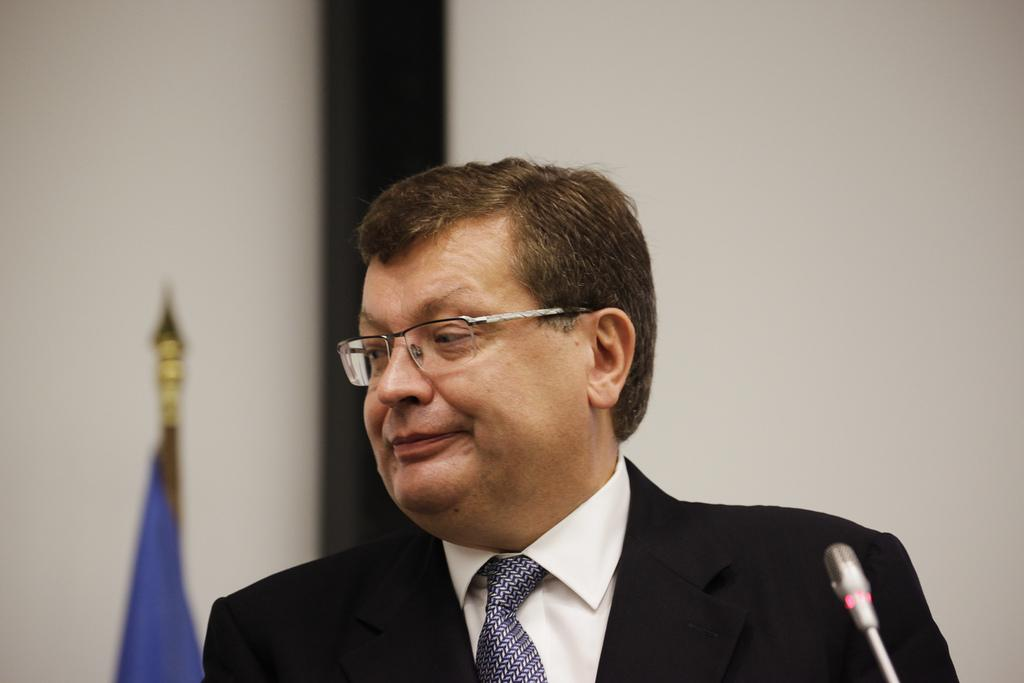Who is the main subject in the picture? There is an old man in the picture. What is the old man wearing? The old man is wearing a black suit and a blue tie. What can be seen in the background of the picture? There is a white wall and a blue color flag in the background of the picture. How does the old man express fear in the picture? There is no indication of fear in the picture; the old man is simply standing there wearing a black suit and a blue tie. 